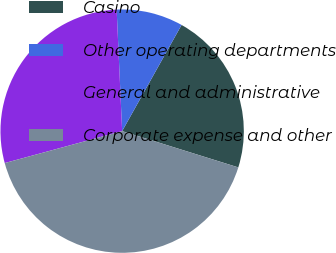Convert chart. <chart><loc_0><loc_0><loc_500><loc_500><pie_chart><fcel>Casino<fcel>Other operating departments<fcel>General and administrative<fcel>Corporate expense and other<nl><fcel>21.7%<fcel>8.84%<fcel>28.51%<fcel>40.96%<nl></chart> 